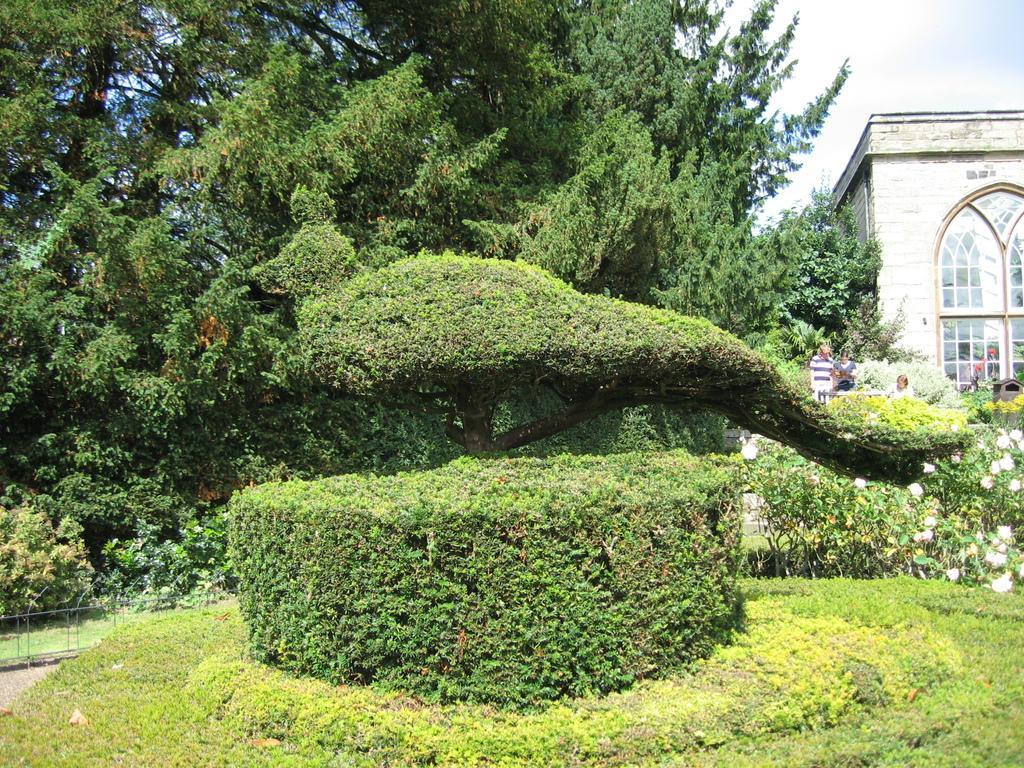Describe this image in one or two sentences. In this image I can see some grass, few plants, few trees which are green in color, few flowers which are white in color and few persons standing. In the background I can see a building and the sky. 